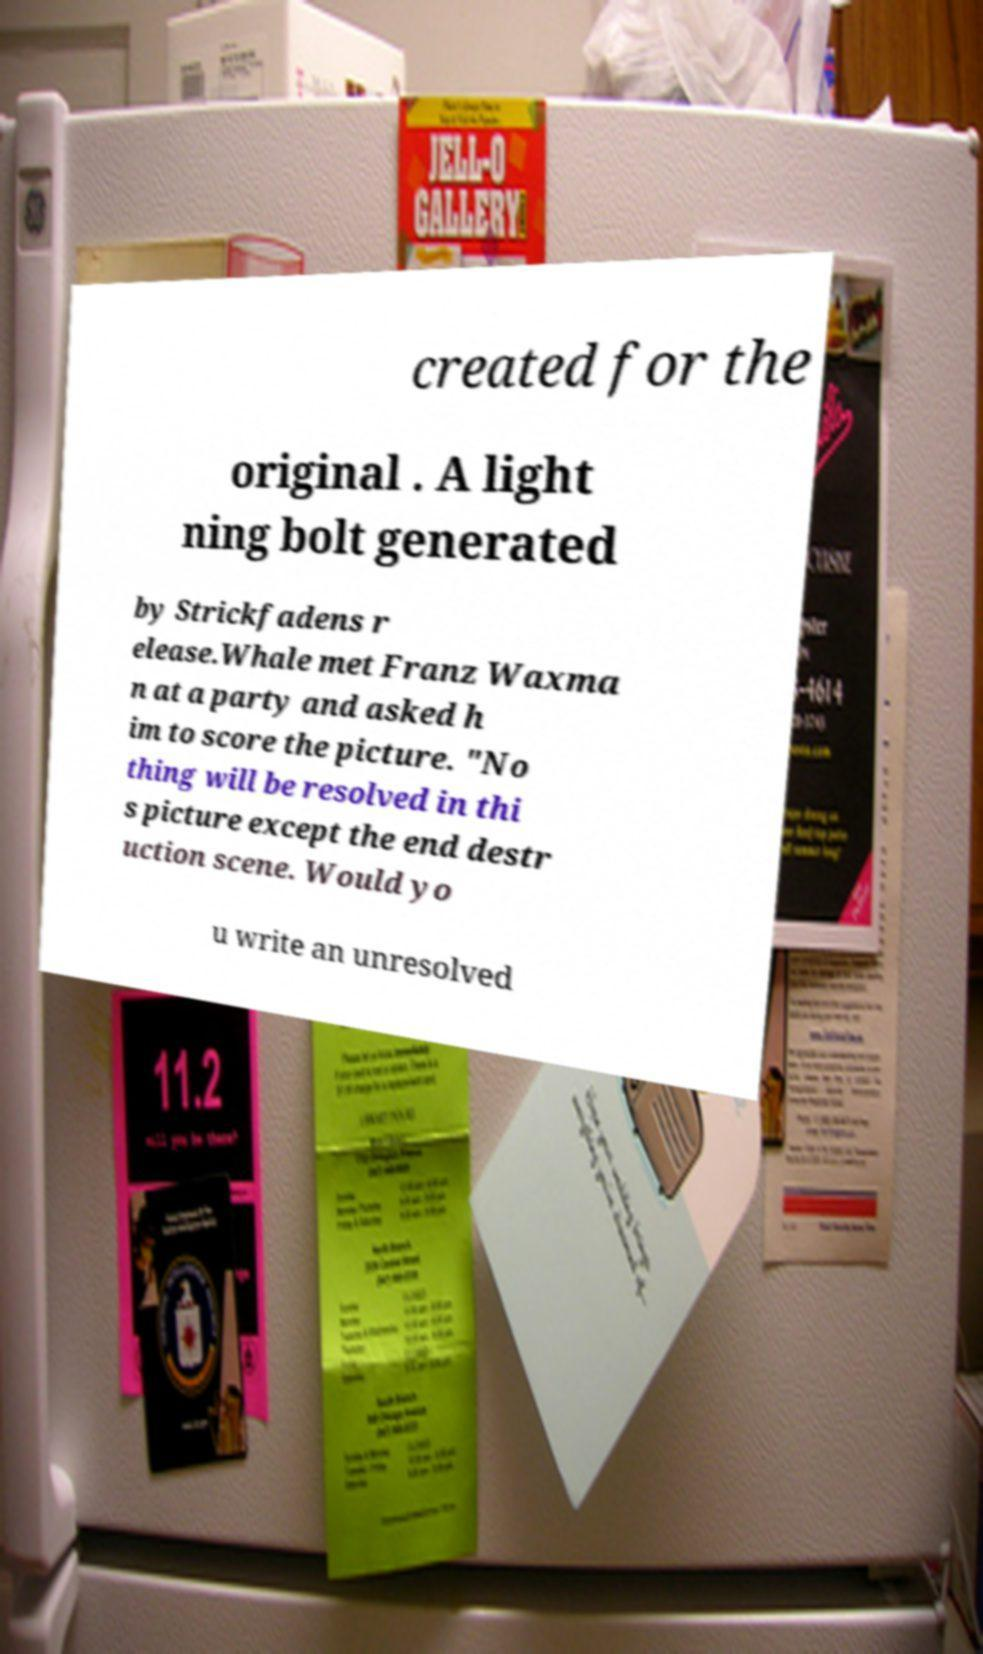What messages or text are displayed in this image? I need them in a readable, typed format. created for the original . A light ning bolt generated by Strickfadens r elease.Whale met Franz Waxma n at a party and asked h im to score the picture. "No thing will be resolved in thi s picture except the end destr uction scene. Would yo u write an unresolved 